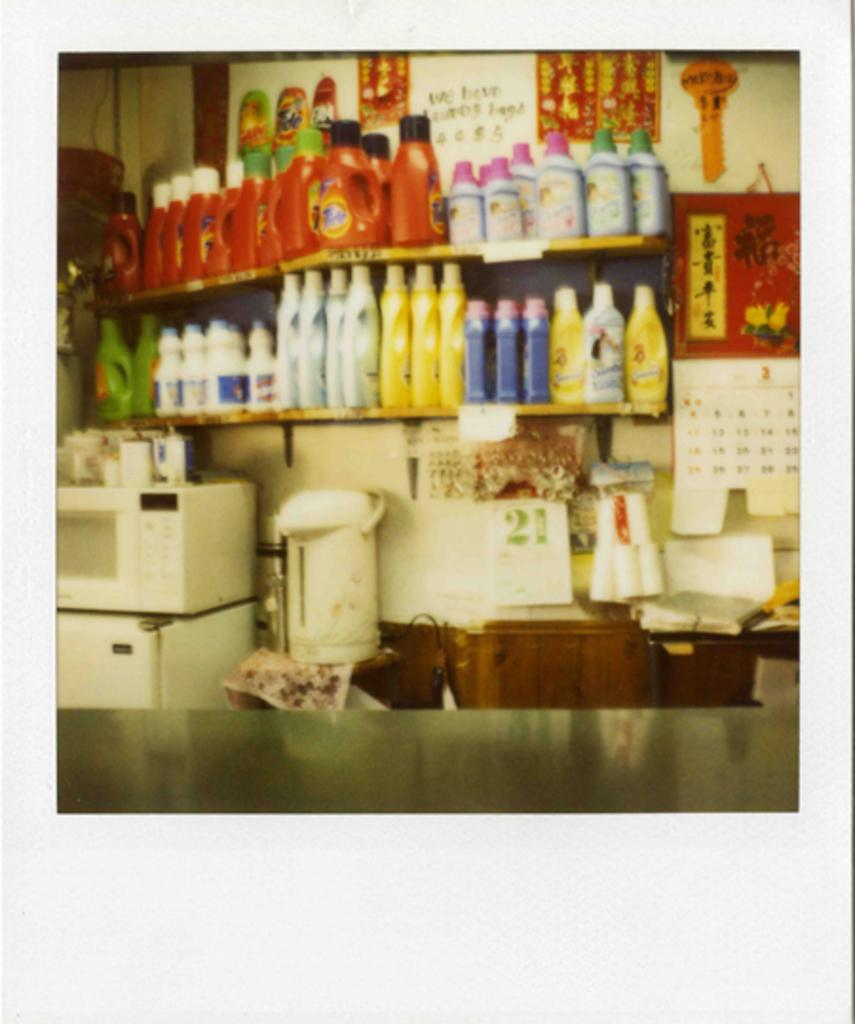<image>
Render a clear and concise summary of the photo. Grocery store with many items including Tide detergent. 